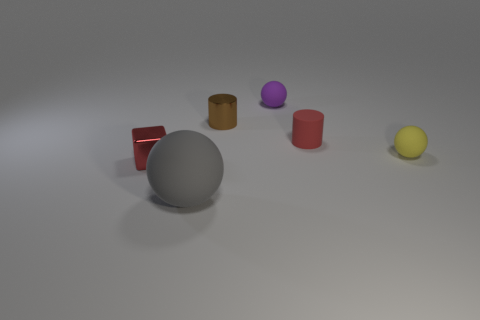What size is the gray rubber thing that is the same shape as the yellow rubber object?
Your answer should be very brief. Large. Is the number of brown cylinders in front of the small yellow sphere the same as the number of red metal objects that are to the right of the gray matte thing?
Keep it short and to the point. Yes. There is a ball that is behind the small brown cylinder; how big is it?
Provide a short and direct response. Small. Is the tiny metallic cylinder the same color as the tiny block?
Your answer should be compact. No. Is there anything else that has the same shape as the brown thing?
Give a very brief answer. Yes. What is the material of the tiny object that is the same color as the tiny cube?
Ensure brevity in your answer.  Rubber. Are there an equal number of brown cylinders that are behind the small brown cylinder and big cyan matte spheres?
Provide a succinct answer. Yes. Are there any tiny red cylinders behind the big gray sphere?
Ensure brevity in your answer.  Yes. There is a yellow thing; does it have the same shape as the tiny red object left of the small red cylinder?
Make the answer very short. No. There is a cylinder that is made of the same material as the purple thing; what color is it?
Give a very brief answer. Red. 